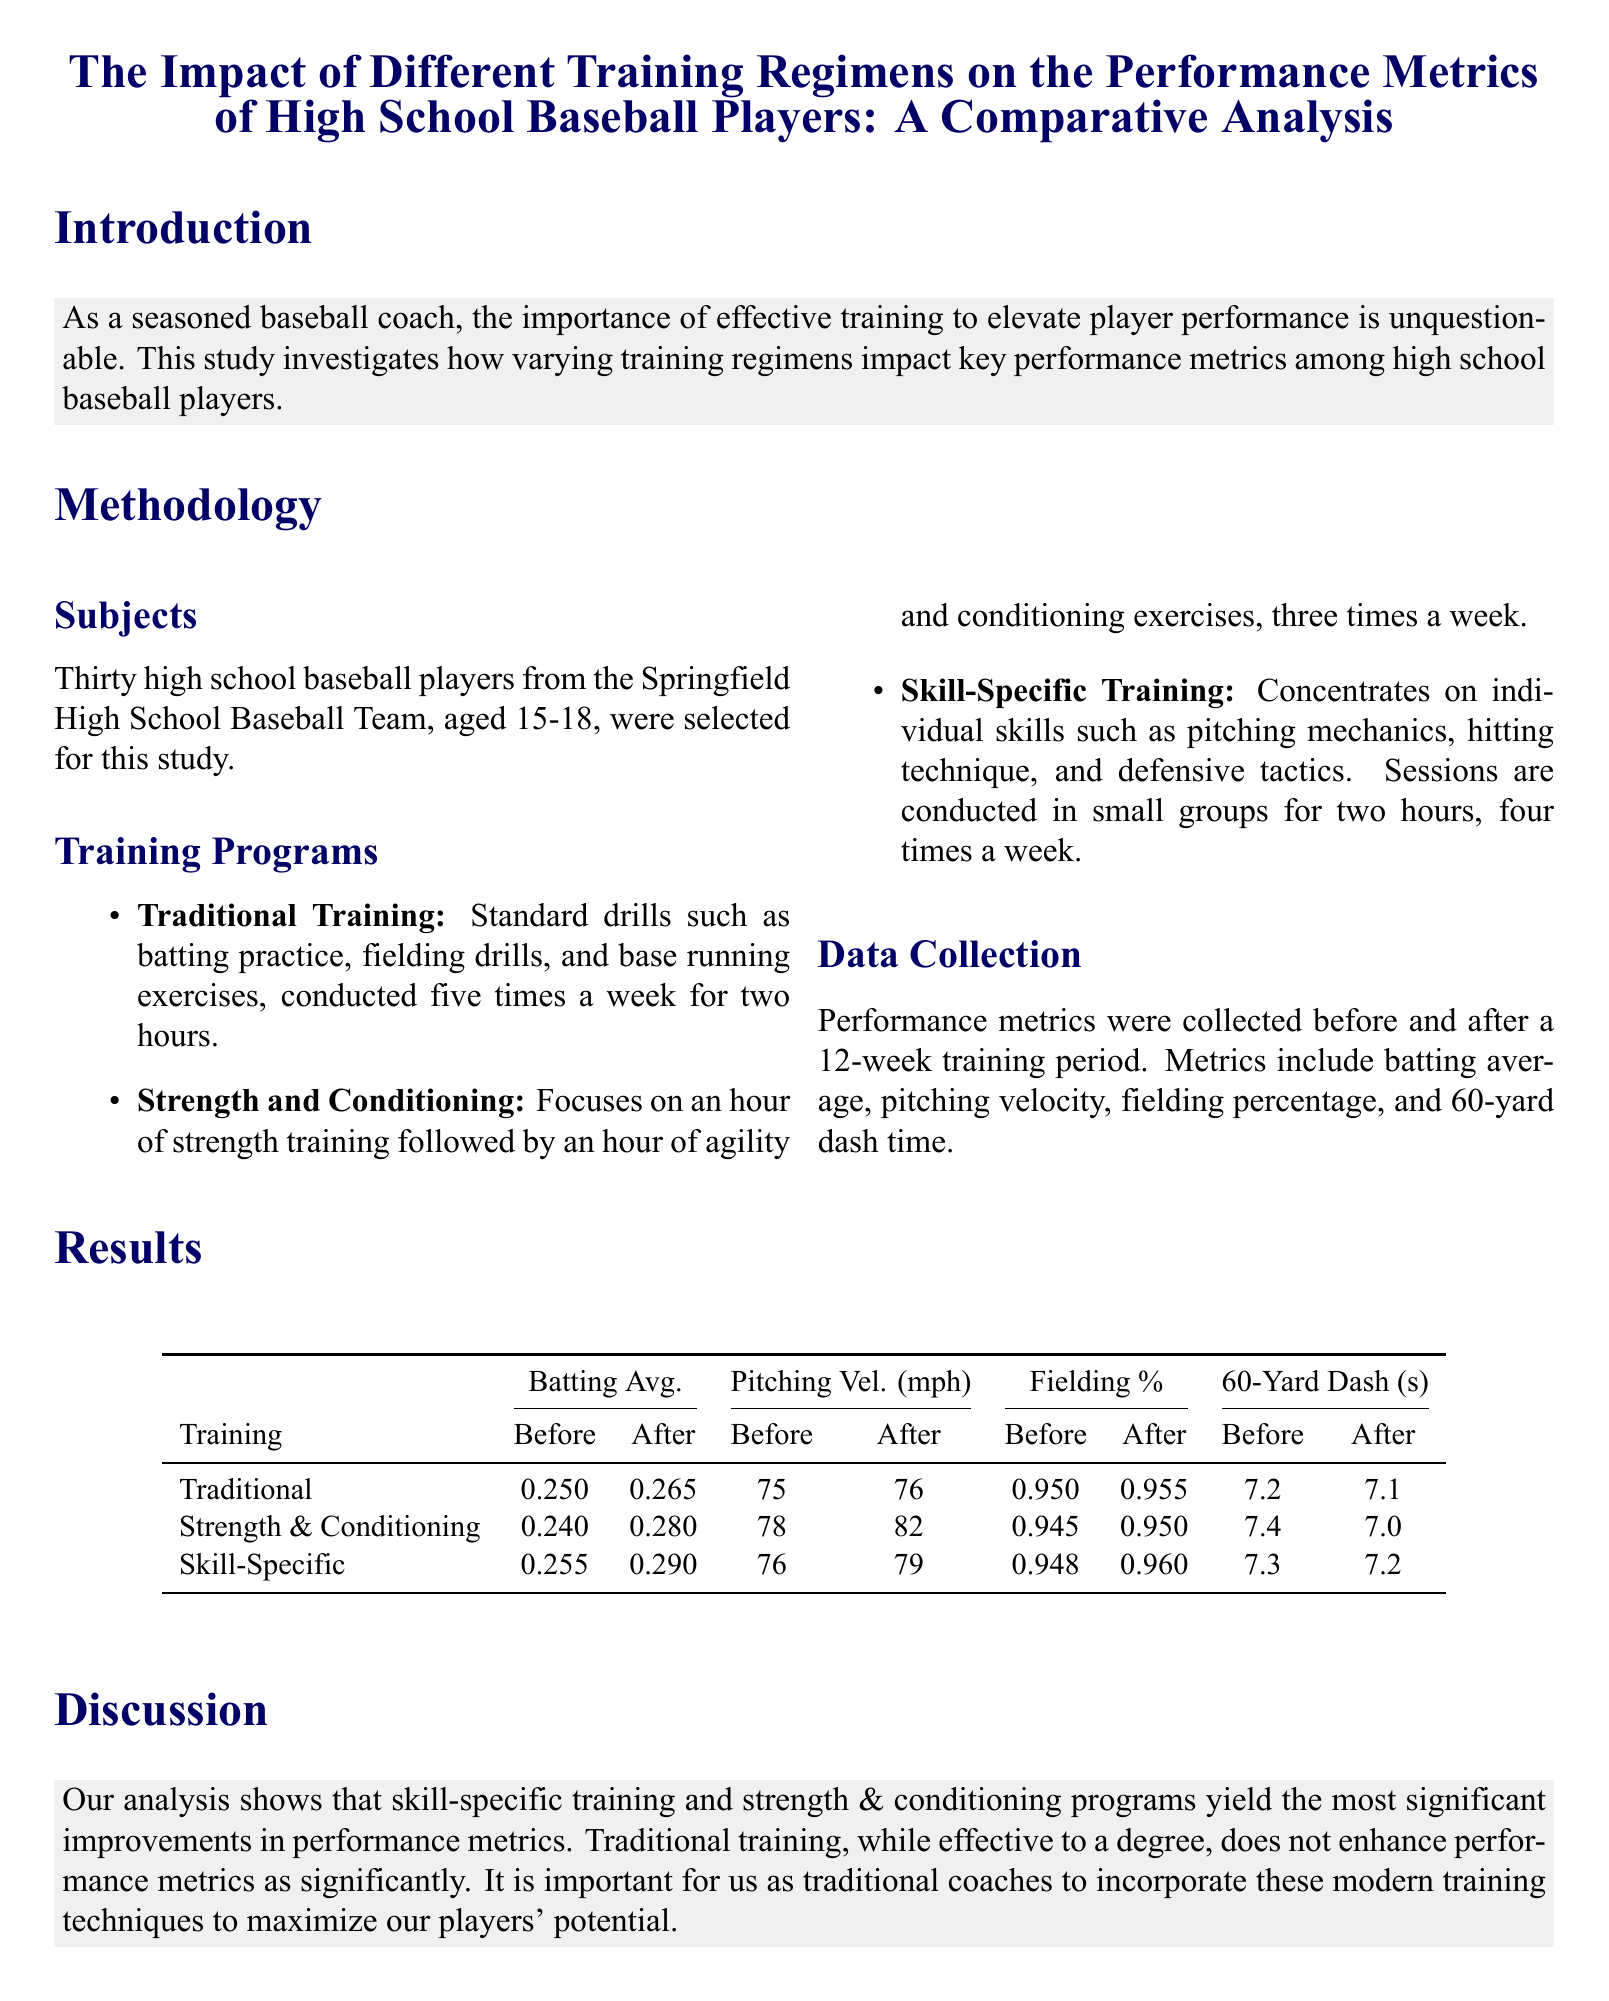What is the age range of subjects in the study? The subjects selected for this study were high school baseball players aged 15-18.
Answer: 15-18 How many training regimens were evaluated in the study? The document outlines three distinct training regimens being evaluated.
Answer: Three What was the batting average of the Traditional group before training? The batting average for the Traditional group before the training period was specified in the results section.
Answer: 0.250 Which training program showed the greatest improvement in pitching velocity? By analyzing the results, we can find which program had the most significant increase in pitching velocity.
Answer: Strength and Conditioning What metric saw a decrease in the 60-yard dash time for the Strength and Conditioning group? The results section lists the 60-yard dash times both before and after the training for each group.
Answer: 7.4 Which training regimen had the highest batting average after training? After evaluating the batting averages after training, we find the regimen with the highest improvement.
Answer: Skill-Specific What is the primary focus of the Strength and Conditioning program? The methodology section describes the main activities involved in the Strength and Conditioning training.
Answer: Strength training and conditioning What conclusion is drawn about traditional training methods? The discussion section summarizes the effectiveness of traditional training methods compared to new training regimens.
Answer: Less significant improvements 